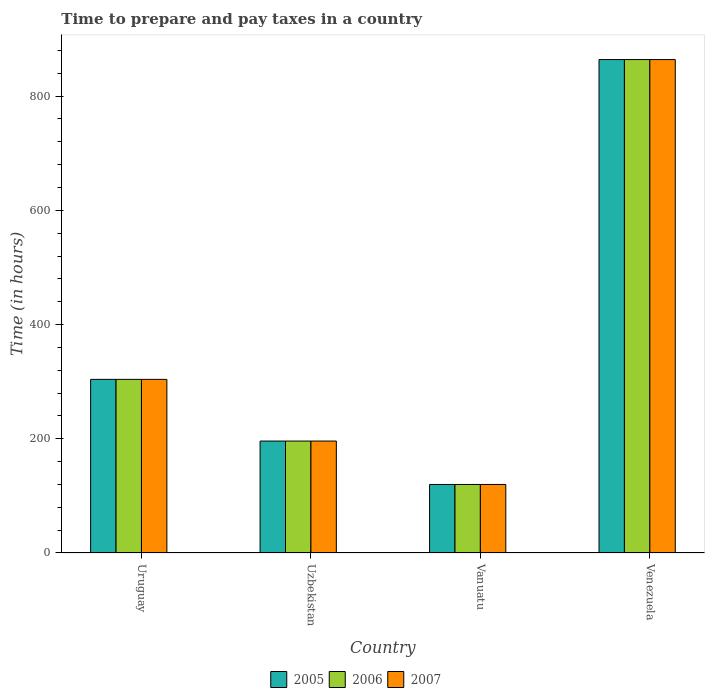How many groups of bars are there?
Offer a very short reply. 4. Are the number of bars per tick equal to the number of legend labels?
Provide a succinct answer. Yes. How many bars are there on the 1st tick from the right?
Your response must be concise. 3. What is the label of the 3rd group of bars from the left?
Ensure brevity in your answer.  Vanuatu. In how many cases, is the number of bars for a given country not equal to the number of legend labels?
Make the answer very short. 0. What is the number of hours required to prepare and pay taxes in 2005 in Uzbekistan?
Keep it short and to the point. 196. Across all countries, what is the maximum number of hours required to prepare and pay taxes in 2007?
Ensure brevity in your answer.  864. Across all countries, what is the minimum number of hours required to prepare and pay taxes in 2007?
Provide a short and direct response. 120. In which country was the number of hours required to prepare and pay taxes in 2005 maximum?
Your response must be concise. Venezuela. In which country was the number of hours required to prepare and pay taxes in 2006 minimum?
Give a very brief answer. Vanuatu. What is the total number of hours required to prepare and pay taxes in 2005 in the graph?
Make the answer very short. 1484. What is the difference between the number of hours required to prepare and pay taxes in 2007 in Uzbekistan and that in Vanuatu?
Give a very brief answer. 76. What is the difference between the number of hours required to prepare and pay taxes in 2007 in Venezuela and the number of hours required to prepare and pay taxes in 2006 in Uzbekistan?
Make the answer very short. 668. What is the average number of hours required to prepare and pay taxes in 2005 per country?
Offer a terse response. 371. What is the ratio of the number of hours required to prepare and pay taxes in 2006 in Uzbekistan to that in Venezuela?
Make the answer very short. 0.23. Is the number of hours required to prepare and pay taxes in 2005 in Vanuatu less than that in Venezuela?
Give a very brief answer. Yes. Is the difference between the number of hours required to prepare and pay taxes in 2007 in Vanuatu and Venezuela greater than the difference between the number of hours required to prepare and pay taxes in 2005 in Vanuatu and Venezuela?
Your answer should be compact. No. What is the difference between the highest and the second highest number of hours required to prepare and pay taxes in 2005?
Ensure brevity in your answer.  560. What is the difference between the highest and the lowest number of hours required to prepare and pay taxes in 2006?
Your response must be concise. 744. In how many countries, is the number of hours required to prepare and pay taxes in 2005 greater than the average number of hours required to prepare and pay taxes in 2005 taken over all countries?
Offer a terse response. 1. What does the 2nd bar from the left in Uzbekistan represents?
Provide a short and direct response. 2006. Is it the case that in every country, the sum of the number of hours required to prepare and pay taxes in 2005 and number of hours required to prepare and pay taxes in 2007 is greater than the number of hours required to prepare and pay taxes in 2006?
Offer a terse response. Yes. How many bars are there?
Ensure brevity in your answer.  12. How many countries are there in the graph?
Provide a succinct answer. 4. What is the difference between two consecutive major ticks on the Y-axis?
Make the answer very short. 200. Does the graph contain any zero values?
Provide a short and direct response. No. Where does the legend appear in the graph?
Make the answer very short. Bottom center. How many legend labels are there?
Ensure brevity in your answer.  3. How are the legend labels stacked?
Ensure brevity in your answer.  Horizontal. What is the title of the graph?
Offer a very short reply. Time to prepare and pay taxes in a country. What is the label or title of the Y-axis?
Your response must be concise. Time (in hours). What is the Time (in hours) of 2005 in Uruguay?
Make the answer very short. 304. What is the Time (in hours) of 2006 in Uruguay?
Your response must be concise. 304. What is the Time (in hours) in 2007 in Uruguay?
Your answer should be very brief. 304. What is the Time (in hours) of 2005 in Uzbekistan?
Give a very brief answer. 196. What is the Time (in hours) in 2006 in Uzbekistan?
Your answer should be compact. 196. What is the Time (in hours) in 2007 in Uzbekistan?
Your answer should be compact. 196. What is the Time (in hours) of 2005 in Vanuatu?
Offer a very short reply. 120. What is the Time (in hours) in 2006 in Vanuatu?
Your answer should be compact. 120. What is the Time (in hours) of 2007 in Vanuatu?
Offer a very short reply. 120. What is the Time (in hours) in 2005 in Venezuela?
Your response must be concise. 864. What is the Time (in hours) of 2006 in Venezuela?
Ensure brevity in your answer.  864. What is the Time (in hours) in 2007 in Venezuela?
Provide a short and direct response. 864. Across all countries, what is the maximum Time (in hours) of 2005?
Provide a short and direct response. 864. Across all countries, what is the maximum Time (in hours) of 2006?
Keep it short and to the point. 864. Across all countries, what is the maximum Time (in hours) in 2007?
Provide a succinct answer. 864. Across all countries, what is the minimum Time (in hours) of 2005?
Your answer should be compact. 120. Across all countries, what is the minimum Time (in hours) in 2006?
Your response must be concise. 120. Across all countries, what is the minimum Time (in hours) of 2007?
Give a very brief answer. 120. What is the total Time (in hours) of 2005 in the graph?
Provide a succinct answer. 1484. What is the total Time (in hours) in 2006 in the graph?
Keep it short and to the point. 1484. What is the total Time (in hours) of 2007 in the graph?
Provide a succinct answer. 1484. What is the difference between the Time (in hours) in 2005 in Uruguay and that in Uzbekistan?
Provide a succinct answer. 108. What is the difference between the Time (in hours) of 2006 in Uruguay and that in Uzbekistan?
Provide a succinct answer. 108. What is the difference between the Time (in hours) of 2007 in Uruguay and that in Uzbekistan?
Ensure brevity in your answer.  108. What is the difference between the Time (in hours) in 2005 in Uruguay and that in Vanuatu?
Give a very brief answer. 184. What is the difference between the Time (in hours) in 2006 in Uruguay and that in Vanuatu?
Keep it short and to the point. 184. What is the difference between the Time (in hours) in 2007 in Uruguay and that in Vanuatu?
Give a very brief answer. 184. What is the difference between the Time (in hours) in 2005 in Uruguay and that in Venezuela?
Your answer should be compact. -560. What is the difference between the Time (in hours) of 2006 in Uruguay and that in Venezuela?
Make the answer very short. -560. What is the difference between the Time (in hours) in 2007 in Uruguay and that in Venezuela?
Your response must be concise. -560. What is the difference between the Time (in hours) of 2005 in Uzbekistan and that in Vanuatu?
Give a very brief answer. 76. What is the difference between the Time (in hours) of 2006 in Uzbekistan and that in Vanuatu?
Offer a very short reply. 76. What is the difference between the Time (in hours) in 2007 in Uzbekistan and that in Vanuatu?
Keep it short and to the point. 76. What is the difference between the Time (in hours) of 2005 in Uzbekistan and that in Venezuela?
Give a very brief answer. -668. What is the difference between the Time (in hours) of 2006 in Uzbekistan and that in Venezuela?
Offer a terse response. -668. What is the difference between the Time (in hours) of 2007 in Uzbekistan and that in Venezuela?
Provide a short and direct response. -668. What is the difference between the Time (in hours) of 2005 in Vanuatu and that in Venezuela?
Provide a succinct answer. -744. What is the difference between the Time (in hours) of 2006 in Vanuatu and that in Venezuela?
Provide a succinct answer. -744. What is the difference between the Time (in hours) of 2007 in Vanuatu and that in Venezuela?
Provide a succinct answer. -744. What is the difference between the Time (in hours) in 2005 in Uruguay and the Time (in hours) in 2006 in Uzbekistan?
Provide a short and direct response. 108. What is the difference between the Time (in hours) of 2005 in Uruguay and the Time (in hours) of 2007 in Uzbekistan?
Keep it short and to the point. 108. What is the difference between the Time (in hours) of 2006 in Uruguay and the Time (in hours) of 2007 in Uzbekistan?
Make the answer very short. 108. What is the difference between the Time (in hours) of 2005 in Uruguay and the Time (in hours) of 2006 in Vanuatu?
Provide a short and direct response. 184. What is the difference between the Time (in hours) of 2005 in Uruguay and the Time (in hours) of 2007 in Vanuatu?
Provide a succinct answer. 184. What is the difference between the Time (in hours) of 2006 in Uruguay and the Time (in hours) of 2007 in Vanuatu?
Your answer should be compact. 184. What is the difference between the Time (in hours) in 2005 in Uruguay and the Time (in hours) in 2006 in Venezuela?
Offer a terse response. -560. What is the difference between the Time (in hours) in 2005 in Uruguay and the Time (in hours) in 2007 in Venezuela?
Your response must be concise. -560. What is the difference between the Time (in hours) of 2006 in Uruguay and the Time (in hours) of 2007 in Venezuela?
Your answer should be compact. -560. What is the difference between the Time (in hours) in 2006 in Uzbekistan and the Time (in hours) in 2007 in Vanuatu?
Offer a very short reply. 76. What is the difference between the Time (in hours) in 2005 in Uzbekistan and the Time (in hours) in 2006 in Venezuela?
Your response must be concise. -668. What is the difference between the Time (in hours) in 2005 in Uzbekistan and the Time (in hours) in 2007 in Venezuela?
Your answer should be very brief. -668. What is the difference between the Time (in hours) of 2006 in Uzbekistan and the Time (in hours) of 2007 in Venezuela?
Offer a very short reply. -668. What is the difference between the Time (in hours) of 2005 in Vanuatu and the Time (in hours) of 2006 in Venezuela?
Keep it short and to the point. -744. What is the difference between the Time (in hours) in 2005 in Vanuatu and the Time (in hours) in 2007 in Venezuela?
Offer a very short reply. -744. What is the difference between the Time (in hours) of 2006 in Vanuatu and the Time (in hours) of 2007 in Venezuela?
Offer a very short reply. -744. What is the average Time (in hours) in 2005 per country?
Your answer should be compact. 371. What is the average Time (in hours) in 2006 per country?
Your answer should be compact. 371. What is the average Time (in hours) in 2007 per country?
Make the answer very short. 371. What is the difference between the Time (in hours) of 2005 and Time (in hours) of 2006 in Uruguay?
Offer a very short reply. 0. What is the difference between the Time (in hours) of 2005 and Time (in hours) of 2006 in Uzbekistan?
Provide a succinct answer. 0. What is the difference between the Time (in hours) of 2006 and Time (in hours) of 2007 in Uzbekistan?
Make the answer very short. 0. What is the difference between the Time (in hours) in 2005 and Time (in hours) in 2006 in Vanuatu?
Your response must be concise. 0. What is the difference between the Time (in hours) in 2005 and Time (in hours) in 2006 in Venezuela?
Your answer should be compact. 0. What is the ratio of the Time (in hours) of 2005 in Uruguay to that in Uzbekistan?
Your answer should be compact. 1.55. What is the ratio of the Time (in hours) in 2006 in Uruguay to that in Uzbekistan?
Keep it short and to the point. 1.55. What is the ratio of the Time (in hours) in 2007 in Uruguay to that in Uzbekistan?
Offer a very short reply. 1.55. What is the ratio of the Time (in hours) of 2005 in Uruguay to that in Vanuatu?
Provide a succinct answer. 2.53. What is the ratio of the Time (in hours) of 2006 in Uruguay to that in Vanuatu?
Keep it short and to the point. 2.53. What is the ratio of the Time (in hours) in 2007 in Uruguay to that in Vanuatu?
Your answer should be very brief. 2.53. What is the ratio of the Time (in hours) of 2005 in Uruguay to that in Venezuela?
Your answer should be very brief. 0.35. What is the ratio of the Time (in hours) in 2006 in Uruguay to that in Venezuela?
Provide a succinct answer. 0.35. What is the ratio of the Time (in hours) of 2007 in Uruguay to that in Venezuela?
Your answer should be compact. 0.35. What is the ratio of the Time (in hours) in 2005 in Uzbekistan to that in Vanuatu?
Offer a terse response. 1.63. What is the ratio of the Time (in hours) in 2006 in Uzbekistan to that in Vanuatu?
Give a very brief answer. 1.63. What is the ratio of the Time (in hours) of 2007 in Uzbekistan to that in Vanuatu?
Offer a very short reply. 1.63. What is the ratio of the Time (in hours) in 2005 in Uzbekistan to that in Venezuela?
Your response must be concise. 0.23. What is the ratio of the Time (in hours) of 2006 in Uzbekistan to that in Venezuela?
Give a very brief answer. 0.23. What is the ratio of the Time (in hours) in 2007 in Uzbekistan to that in Venezuela?
Give a very brief answer. 0.23. What is the ratio of the Time (in hours) of 2005 in Vanuatu to that in Venezuela?
Offer a very short reply. 0.14. What is the ratio of the Time (in hours) in 2006 in Vanuatu to that in Venezuela?
Make the answer very short. 0.14. What is the ratio of the Time (in hours) of 2007 in Vanuatu to that in Venezuela?
Offer a very short reply. 0.14. What is the difference between the highest and the second highest Time (in hours) of 2005?
Provide a succinct answer. 560. What is the difference between the highest and the second highest Time (in hours) of 2006?
Make the answer very short. 560. What is the difference between the highest and the second highest Time (in hours) in 2007?
Keep it short and to the point. 560. What is the difference between the highest and the lowest Time (in hours) in 2005?
Make the answer very short. 744. What is the difference between the highest and the lowest Time (in hours) of 2006?
Give a very brief answer. 744. What is the difference between the highest and the lowest Time (in hours) of 2007?
Provide a succinct answer. 744. 